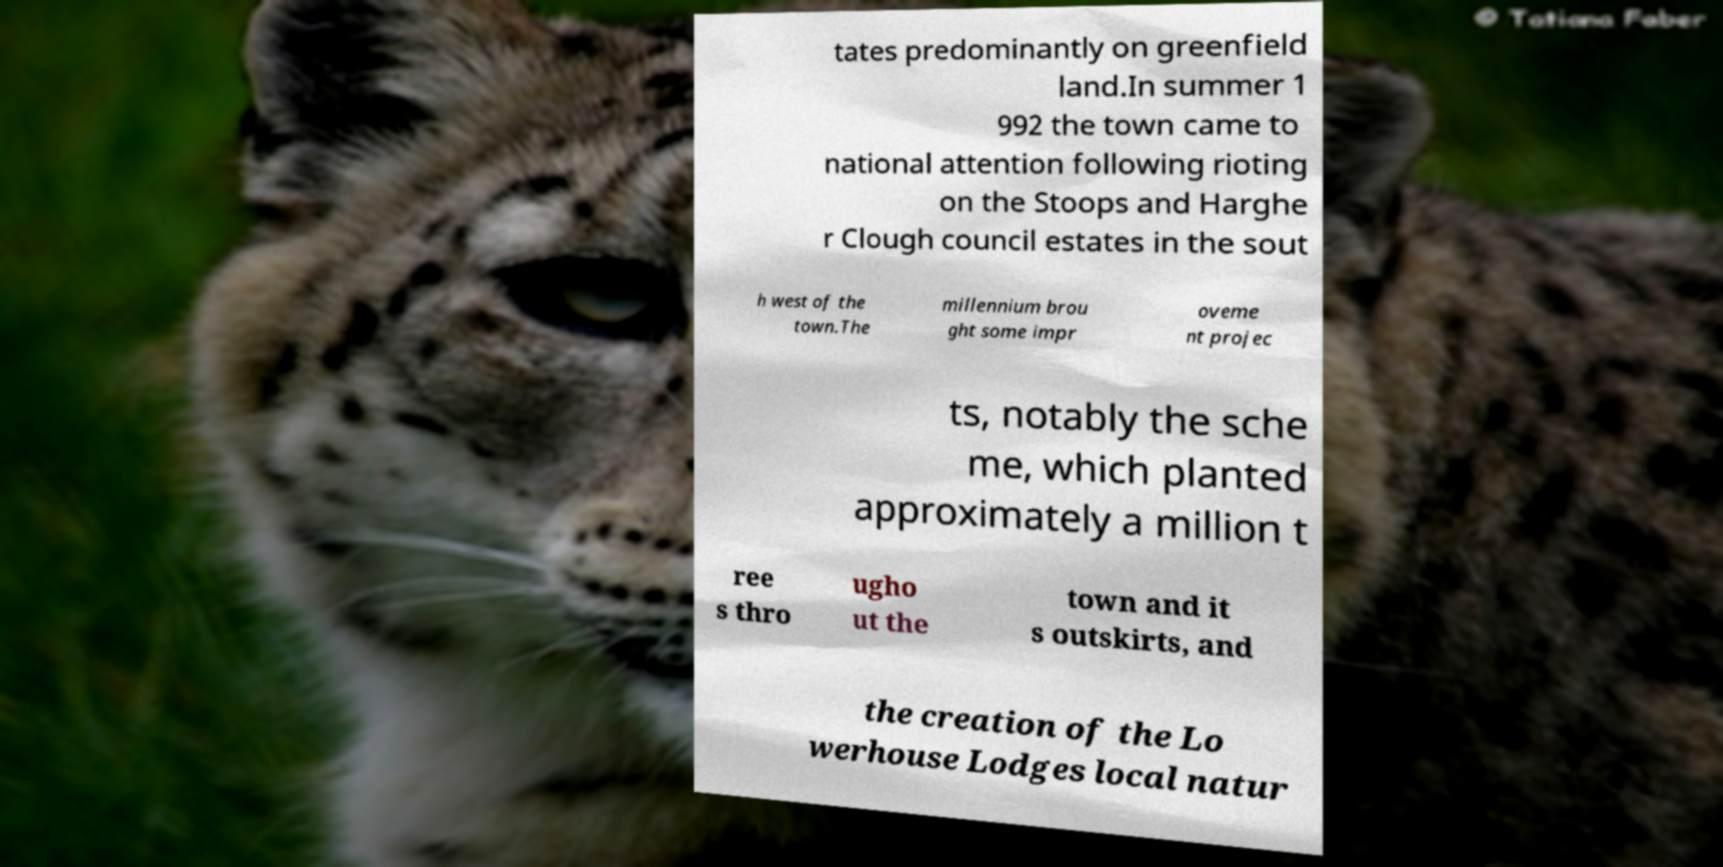Please identify and transcribe the text found in this image. tates predominantly on greenfield land.In summer 1 992 the town came to national attention following rioting on the Stoops and Harghe r Clough council estates in the sout h west of the town.The millennium brou ght some impr oveme nt projec ts, notably the sche me, which planted approximately a million t ree s thro ugho ut the town and it s outskirts, and the creation of the Lo werhouse Lodges local natur 